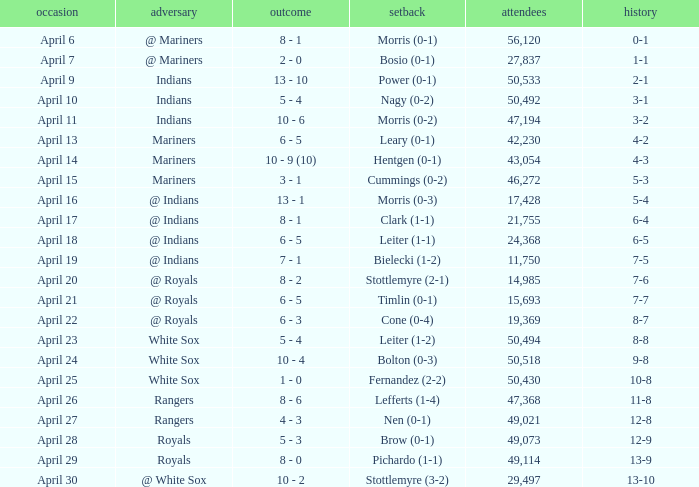What scored is recorded on April 24? 10 - 4. 